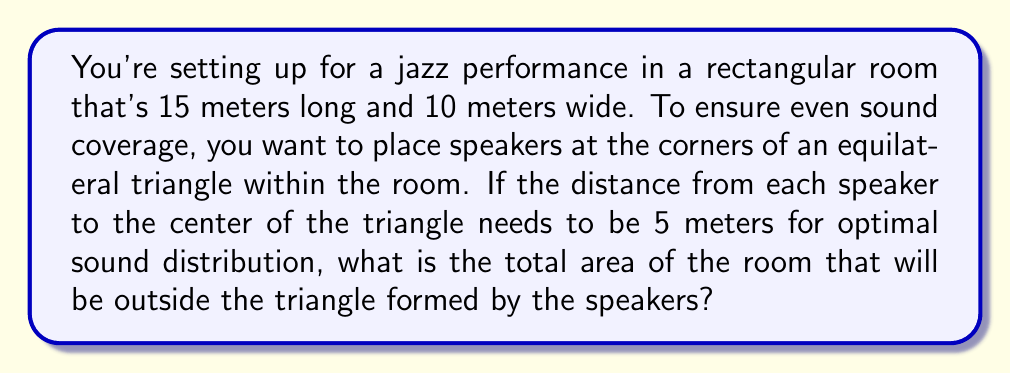Solve this math problem. Let's approach this step-by-step:

1) First, we need to calculate the side length of the equilateral triangle. In an equilateral triangle, the distance from the center to any vertex is equal to the side length multiplied by $\frac{\sqrt{3}}{3}$. So:

   $5 = a \cdot \frac{\sqrt{3}}{3}$, where $a$ is the side length.
   
   $a = 5 \cdot \frac{3}{\sqrt{3}} = 5\sqrt{3}$ meters

2) Now we can calculate the area of the equilateral triangle:

   $A_{triangle} = \frac{\sqrt{3}}{4}a^2 = \frac{\sqrt{3}}{4}(5\sqrt{3})^2 = \frac{75\sqrt{3}}{4}$ square meters

3) The area of the rectangular room is:

   $A_{room} = 15 \cdot 10 = 150$ square meters

4) The area outside the triangle is the difference between these:

   $A_{outside} = A_{room} - A_{triangle} = 150 - \frac{75\sqrt{3}}{4}$ square meters

5) To simplify:
   
   $A_{outside} = \frac{600}{4} - \frac{75\sqrt{3}}{4} = \frac{600 - 75\sqrt{3}}{4}$ square meters

Thus, the area outside the triangle is $\frac{600 - 75\sqrt{3}}{4}$ square meters.

[asy]
import geometry;

size(200);

pair A = (0,0);
pair B = (15,0);
pair C = (15,10);
pair D = (0,10);

draw(A--B--C--D--cycle);

pair E = (5,5*sqrt(3));
pair F = (10,0);
pair G = (0,5*sqrt(3));

draw(E--F--G--cycle, red);

label("15m", (7.5,-0.5));
label("10m", (15.5,5));

dot("A", E, N);
dot("B", F, S);
dot("C", G, S);

[/asy]
Answer: $\frac{600 - 75\sqrt{3}}{4}$ square meters 